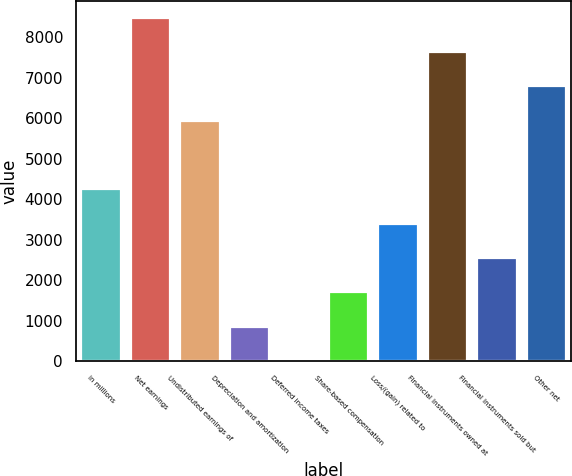Convert chart to OTSL. <chart><loc_0><loc_0><loc_500><loc_500><bar_chart><fcel>in millions<fcel>Net earnings<fcel>Undistributed earnings of<fcel>Depreciation and amortization<fcel>Deferred income taxes<fcel>Share-based compensation<fcel>Loss/(gain) related to<fcel>Financial instruments owned at<fcel>Financial instruments sold but<fcel>Other net<nl><fcel>4240.5<fcel>8477<fcel>5935.1<fcel>851.3<fcel>4<fcel>1698.6<fcel>3393.2<fcel>7629.7<fcel>2545.9<fcel>6782.4<nl></chart> 